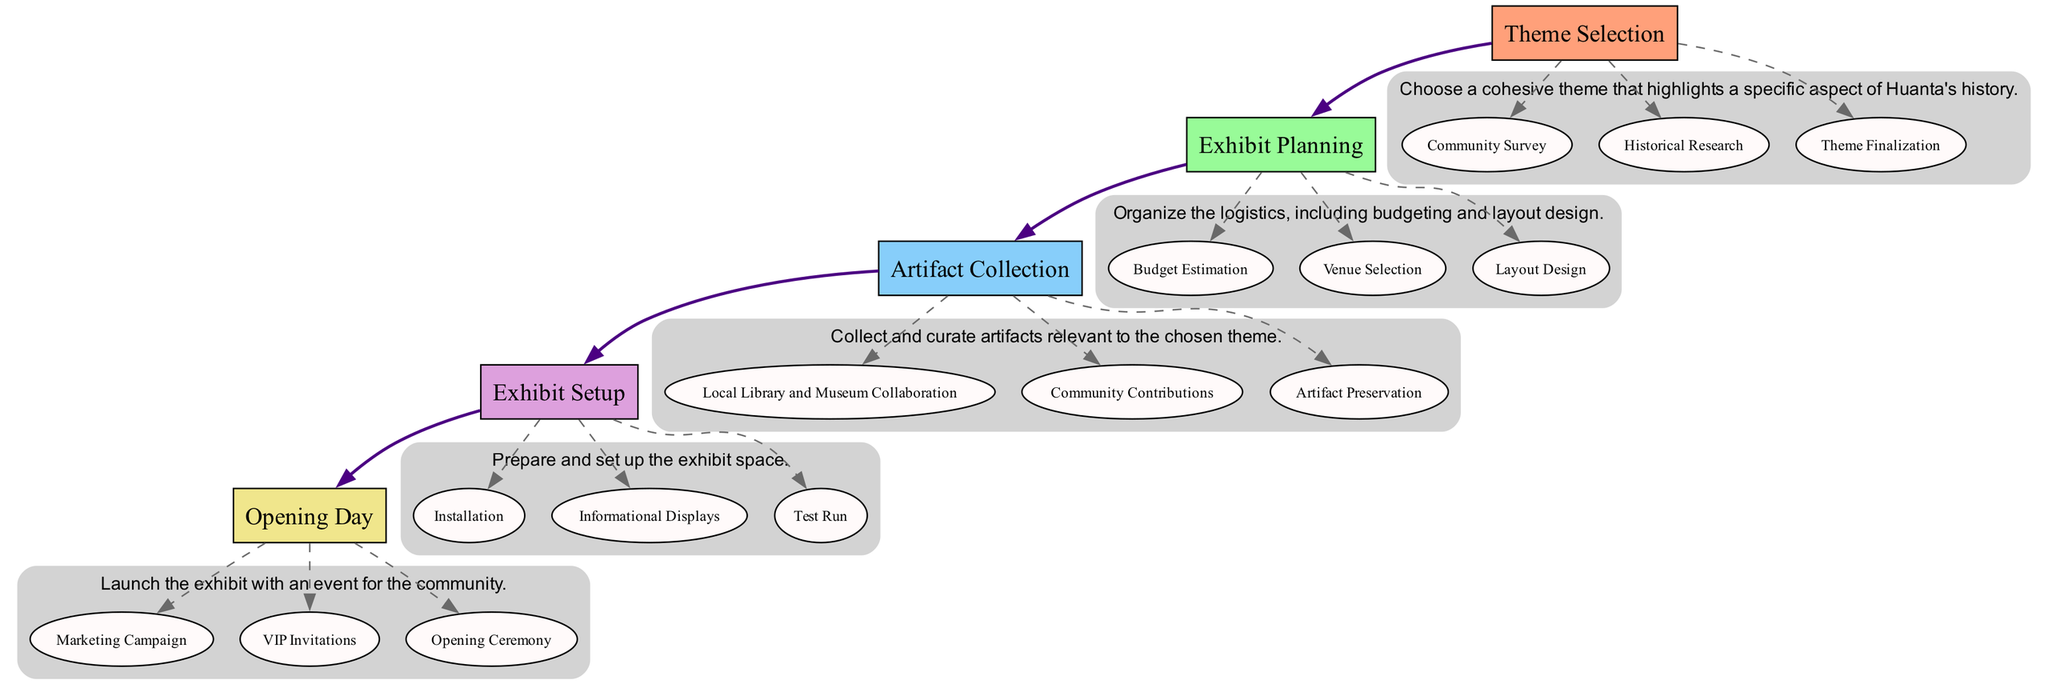What is the first main element in the flow chart? The first main element is labeled "Theme Selection." It is identified by the position at the top of the diagram, as the structure follows a top-to-bottom flow.
Answer: Theme Selection How many main elements are there in the diagram? There are five main elements named "Theme Selection," "Exhibit Planning," "Artifact Collection," "Exhibit Setup," and "Opening Day." By counting each of these elements in the diagram, we determine the total number.
Answer: 5 What is the last action under "Exhibit Setup"? The last action listed under "Exhibit Setup" is "Test Run." It is the third item in the cluster of actions related to the "Exhibit Setup" element.
Answer: Test Run What type of relationship connects the main elements? The main elements are connected with solid edges indicating a flow from one to the next, which represents a sequential relationship in the process of curating the local history exhibit.
Answer: Sequential Which action is related to gathering input from the community? The action related to gathering input from the community is "Community Survey," which is part of the "Theme Selection" element. This action specifically seeks involvement from local residents regarding theme ideas.
Answer: Community Survey How does "Artifact Preservation" relate to "Artifact Collection"? "Artifact Preservation" is an action under the "Artifact Collection" main element. This indicates that the preservation of artifacts is essential to the collection process and follows the effort of curating relevant items.
Answer: It is an action under Artifact Collection What is the focus of the second element in the flow chart? The second element in the flow chart is "Exhibit Planning," which focuses on organizing logistics for the exhibit, including budgeting and layout design. It aims at efficient preparation and structuring of the exhibit details.
Answer: Organizing logistics What is the significance of "VIP Invitations"? "VIP Invitations" is an action related to the "Opening Day" element, indicating that inviting local historians, community leaders, and dignitaries is important for the prestige and attendance at the exhibit's launch.
Answer: Important for attendance Which action comes after "Budget Estimation"? The action that comes after "Budget Estimation" in the "Exhibit Planning" sequence is "Venue Selection." This shows the logical progression from estimating costs to determining where the exhibit will be held.
Answer: Venue Selection 